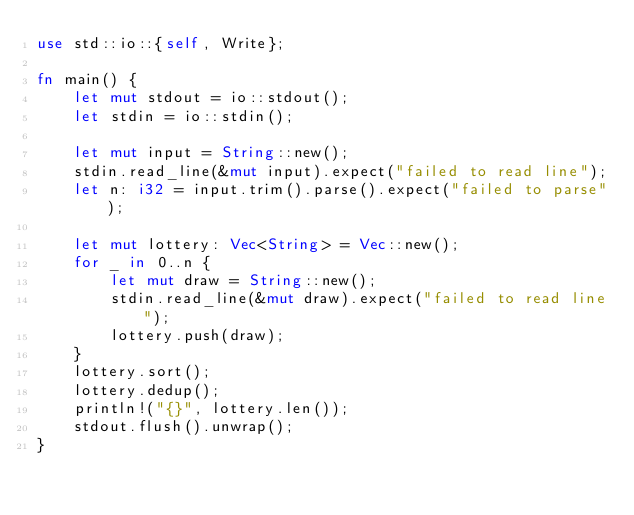<code> <loc_0><loc_0><loc_500><loc_500><_Rust_>use std::io::{self, Write};

fn main() {
    let mut stdout = io::stdout();
    let stdin = io::stdin();

    let mut input = String::new();
    stdin.read_line(&mut input).expect("failed to read line");
    let n: i32 = input.trim().parse().expect("failed to parse");

    let mut lottery: Vec<String> = Vec::new();
    for _ in 0..n {
        let mut draw = String::new();
        stdin.read_line(&mut draw).expect("failed to read line");
        lottery.push(draw);
    }
    lottery.sort();
    lottery.dedup();
    println!("{}", lottery.len());
    stdout.flush().unwrap();
}
</code> 